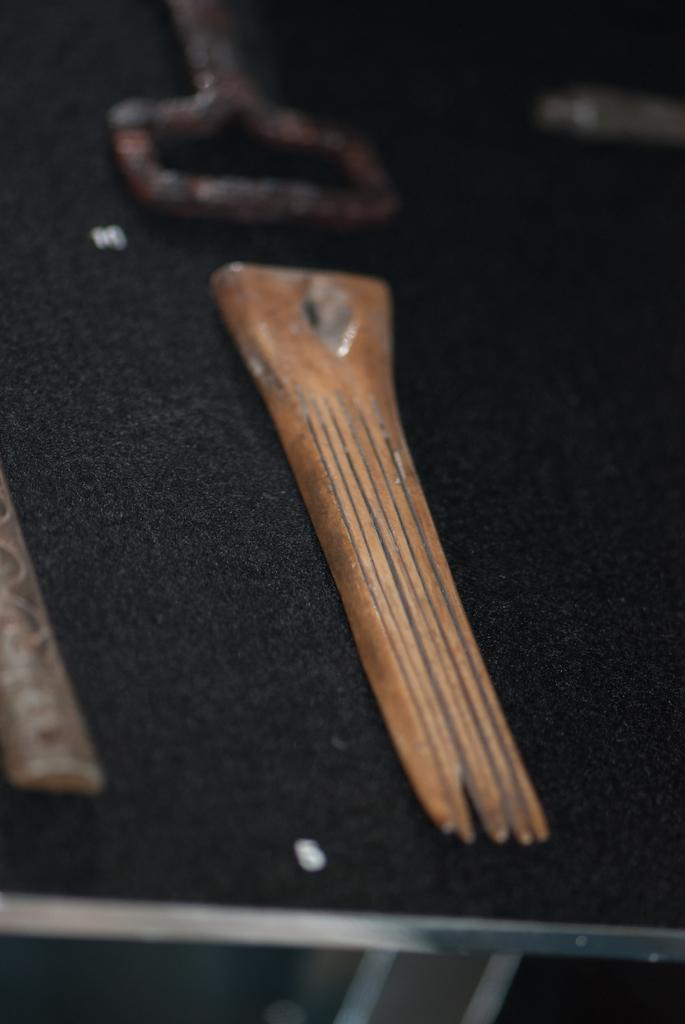What material is the object on the table made of? The wooden object on the table is made of wood. Can you describe any other objects in the image? Yes, there are metal objects in the image. What type of train can be seen in the image? There is no train present in the image. What unit of measurement is used to describe the size of the wooden object? The facts do not provide any information about the size or unit of measurement for the wooden object. 